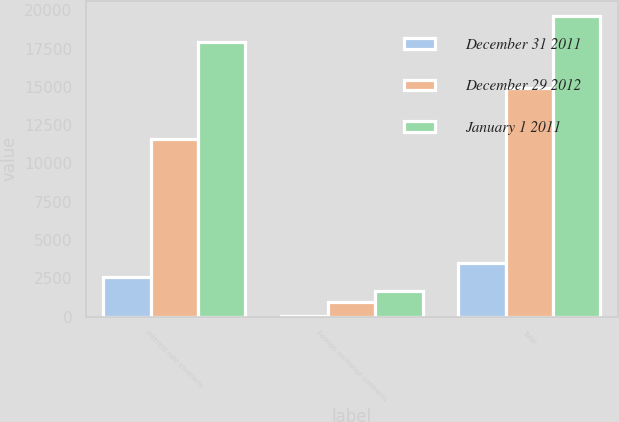Convert chart to OTSL. <chart><loc_0><loc_0><loc_500><loc_500><stacked_bar_chart><ecel><fcel>Interest rate contracts<fcel>Foreign exchange contracts<fcel>Total<nl><fcel>December 31 2011<fcel>2560<fcel>47<fcel>3484<nl><fcel>December 29 2012<fcel>11621<fcel>969<fcel>14904<nl><fcel>January 1 2011<fcel>17964<fcel>1676<fcel>19640<nl></chart> 